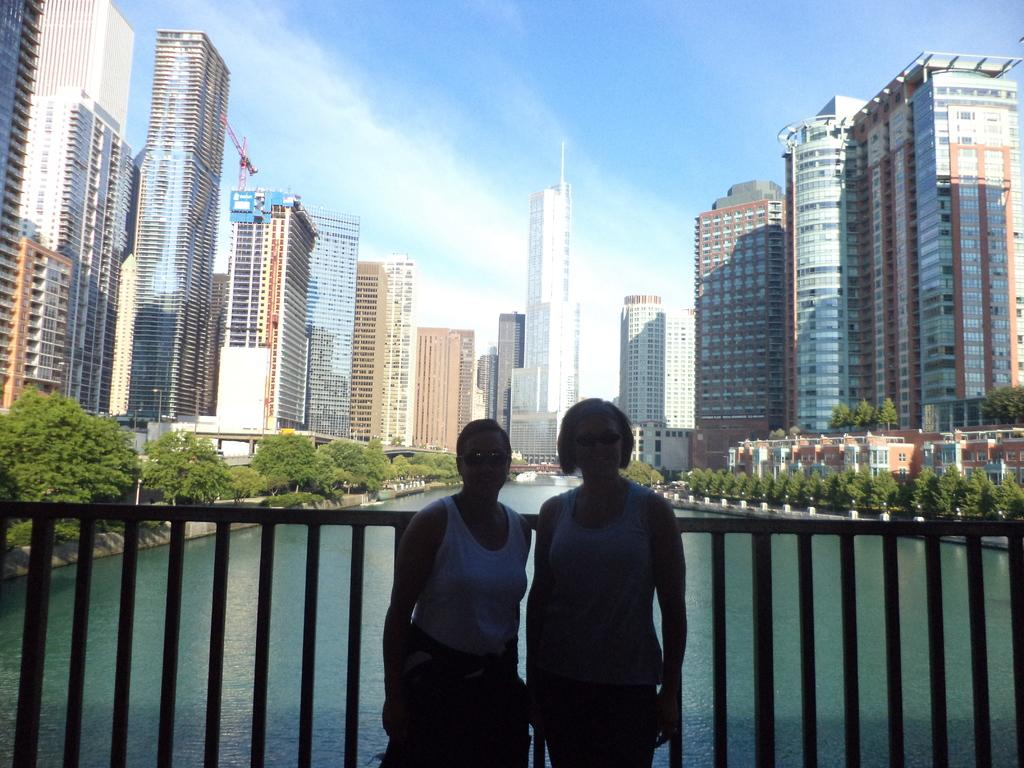What type of structures can be seen in the image? There are buildings with windows in the image. How many people are present in the image? There are two people standing in the image. What natural element is visible in the image? There is water visible in the image. What type of vegetation is present in the image? There are trees in the image. What part of the natural environment is visible in the image? The sky is visible in the image. What type of watch is the person wearing in the image? There is no watch visible in the image; only the people, buildings, water, trees, and sky are present. What type of skirt is the person wearing in the image? There is no skirt visible in the image; only the people, buildings, water, trees, and sky are present. 